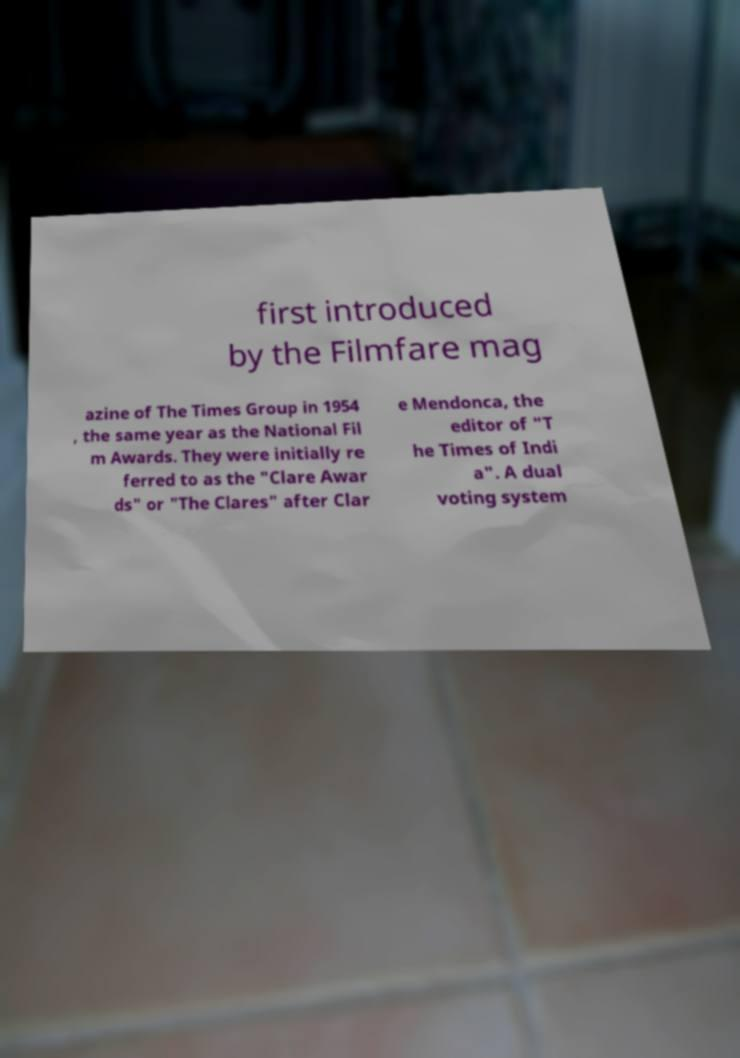I need the written content from this picture converted into text. Can you do that? first introduced by the Filmfare mag azine of The Times Group in 1954 , the same year as the National Fil m Awards. They were initially re ferred to as the "Clare Awar ds" or "The Clares" after Clar e Mendonca, the editor of "T he Times of Indi a". A dual voting system 